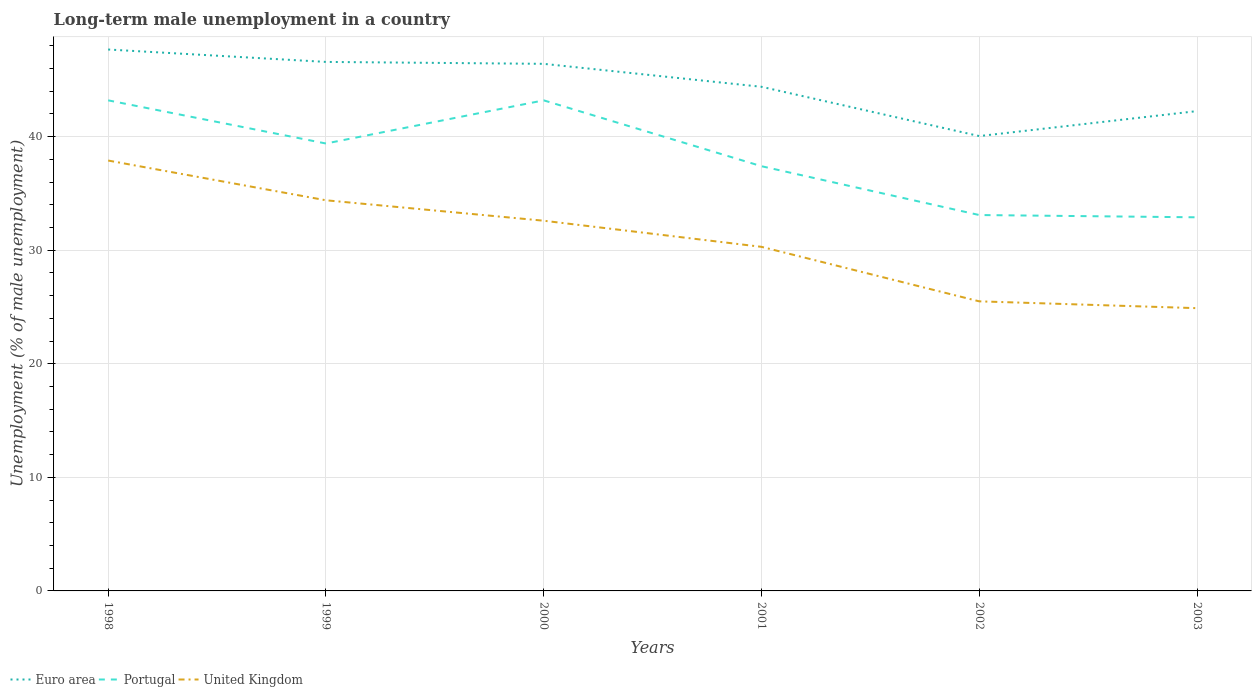How many different coloured lines are there?
Give a very brief answer. 3. Across all years, what is the maximum percentage of long-term unemployed male population in Euro area?
Give a very brief answer. 40.05. What is the total percentage of long-term unemployed male population in United Kingdom in the graph?
Provide a short and direct response. 13. What is the difference between the highest and the second highest percentage of long-term unemployed male population in Portugal?
Offer a very short reply. 10.3. What is the difference between the highest and the lowest percentage of long-term unemployed male population in Euro area?
Your response must be concise. 3. Is the percentage of long-term unemployed male population in Euro area strictly greater than the percentage of long-term unemployed male population in United Kingdom over the years?
Your response must be concise. No. How many lines are there?
Make the answer very short. 3. What is the difference between two consecutive major ticks on the Y-axis?
Offer a terse response. 10. How are the legend labels stacked?
Ensure brevity in your answer.  Horizontal. What is the title of the graph?
Your response must be concise. Long-term male unemployment in a country. What is the label or title of the X-axis?
Your response must be concise. Years. What is the label or title of the Y-axis?
Offer a very short reply. Unemployment (% of male unemployment). What is the Unemployment (% of male unemployment) in Euro area in 1998?
Make the answer very short. 47.68. What is the Unemployment (% of male unemployment) in Portugal in 1998?
Your answer should be very brief. 43.2. What is the Unemployment (% of male unemployment) of United Kingdom in 1998?
Keep it short and to the point. 37.9. What is the Unemployment (% of male unemployment) in Euro area in 1999?
Keep it short and to the point. 46.58. What is the Unemployment (% of male unemployment) of Portugal in 1999?
Give a very brief answer. 39.4. What is the Unemployment (% of male unemployment) in United Kingdom in 1999?
Keep it short and to the point. 34.4. What is the Unemployment (% of male unemployment) in Euro area in 2000?
Keep it short and to the point. 46.42. What is the Unemployment (% of male unemployment) of Portugal in 2000?
Provide a short and direct response. 43.2. What is the Unemployment (% of male unemployment) in United Kingdom in 2000?
Your response must be concise. 32.6. What is the Unemployment (% of male unemployment) of Euro area in 2001?
Make the answer very short. 44.39. What is the Unemployment (% of male unemployment) in Portugal in 2001?
Give a very brief answer. 37.4. What is the Unemployment (% of male unemployment) of United Kingdom in 2001?
Keep it short and to the point. 30.3. What is the Unemployment (% of male unemployment) of Euro area in 2002?
Your response must be concise. 40.05. What is the Unemployment (% of male unemployment) of Portugal in 2002?
Your answer should be very brief. 33.1. What is the Unemployment (% of male unemployment) of United Kingdom in 2002?
Offer a terse response. 25.5. What is the Unemployment (% of male unemployment) of Euro area in 2003?
Offer a very short reply. 42.25. What is the Unemployment (% of male unemployment) of Portugal in 2003?
Provide a succinct answer. 32.9. What is the Unemployment (% of male unemployment) of United Kingdom in 2003?
Provide a short and direct response. 24.9. Across all years, what is the maximum Unemployment (% of male unemployment) of Euro area?
Your response must be concise. 47.68. Across all years, what is the maximum Unemployment (% of male unemployment) of Portugal?
Your response must be concise. 43.2. Across all years, what is the maximum Unemployment (% of male unemployment) in United Kingdom?
Your response must be concise. 37.9. Across all years, what is the minimum Unemployment (% of male unemployment) of Euro area?
Your answer should be very brief. 40.05. Across all years, what is the minimum Unemployment (% of male unemployment) of Portugal?
Provide a short and direct response. 32.9. Across all years, what is the minimum Unemployment (% of male unemployment) of United Kingdom?
Your answer should be compact. 24.9. What is the total Unemployment (% of male unemployment) in Euro area in the graph?
Your answer should be compact. 267.38. What is the total Unemployment (% of male unemployment) in Portugal in the graph?
Offer a very short reply. 229.2. What is the total Unemployment (% of male unemployment) in United Kingdom in the graph?
Offer a terse response. 185.6. What is the difference between the Unemployment (% of male unemployment) in Euro area in 1998 and that in 1999?
Your response must be concise. 1.09. What is the difference between the Unemployment (% of male unemployment) of United Kingdom in 1998 and that in 1999?
Offer a terse response. 3.5. What is the difference between the Unemployment (% of male unemployment) in Euro area in 1998 and that in 2000?
Your response must be concise. 1.26. What is the difference between the Unemployment (% of male unemployment) of Portugal in 1998 and that in 2000?
Give a very brief answer. 0. What is the difference between the Unemployment (% of male unemployment) in United Kingdom in 1998 and that in 2000?
Give a very brief answer. 5.3. What is the difference between the Unemployment (% of male unemployment) in Euro area in 1998 and that in 2001?
Keep it short and to the point. 3.28. What is the difference between the Unemployment (% of male unemployment) of United Kingdom in 1998 and that in 2001?
Keep it short and to the point. 7.6. What is the difference between the Unemployment (% of male unemployment) in Euro area in 1998 and that in 2002?
Make the answer very short. 7.62. What is the difference between the Unemployment (% of male unemployment) in Portugal in 1998 and that in 2002?
Your answer should be compact. 10.1. What is the difference between the Unemployment (% of male unemployment) in United Kingdom in 1998 and that in 2002?
Give a very brief answer. 12.4. What is the difference between the Unemployment (% of male unemployment) in Euro area in 1998 and that in 2003?
Your answer should be very brief. 5.42. What is the difference between the Unemployment (% of male unemployment) of United Kingdom in 1998 and that in 2003?
Your answer should be very brief. 13. What is the difference between the Unemployment (% of male unemployment) in Euro area in 1999 and that in 2000?
Provide a succinct answer. 0.17. What is the difference between the Unemployment (% of male unemployment) of United Kingdom in 1999 and that in 2000?
Your answer should be very brief. 1.8. What is the difference between the Unemployment (% of male unemployment) in Euro area in 1999 and that in 2001?
Offer a terse response. 2.19. What is the difference between the Unemployment (% of male unemployment) of United Kingdom in 1999 and that in 2001?
Your response must be concise. 4.1. What is the difference between the Unemployment (% of male unemployment) of Euro area in 1999 and that in 2002?
Keep it short and to the point. 6.53. What is the difference between the Unemployment (% of male unemployment) in Euro area in 1999 and that in 2003?
Your answer should be very brief. 4.33. What is the difference between the Unemployment (% of male unemployment) of United Kingdom in 1999 and that in 2003?
Provide a succinct answer. 9.5. What is the difference between the Unemployment (% of male unemployment) of Euro area in 2000 and that in 2001?
Make the answer very short. 2.02. What is the difference between the Unemployment (% of male unemployment) of United Kingdom in 2000 and that in 2001?
Make the answer very short. 2.3. What is the difference between the Unemployment (% of male unemployment) in Euro area in 2000 and that in 2002?
Your answer should be very brief. 6.36. What is the difference between the Unemployment (% of male unemployment) in United Kingdom in 2000 and that in 2002?
Provide a short and direct response. 7.1. What is the difference between the Unemployment (% of male unemployment) of Euro area in 2000 and that in 2003?
Keep it short and to the point. 4.16. What is the difference between the Unemployment (% of male unemployment) of Portugal in 2000 and that in 2003?
Your answer should be very brief. 10.3. What is the difference between the Unemployment (% of male unemployment) in United Kingdom in 2000 and that in 2003?
Make the answer very short. 7.7. What is the difference between the Unemployment (% of male unemployment) of Euro area in 2001 and that in 2002?
Your response must be concise. 4.34. What is the difference between the Unemployment (% of male unemployment) of Euro area in 2001 and that in 2003?
Give a very brief answer. 2.14. What is the difference between the Unemployment (% of male unemployment) of United Kingdom in 2001 and that in 2003?
Offer a very short reply. 5.4. What is the difference between the Unemployment (% of male unemployment) of Euro area in 2002 and that in 2003?
Give a very brief answer. -2.2. What is the difference between the Unemployment (% of male unemployment) of Portugal in 2002 and that in 2003?
Give a very brief answer. 0.2. What is the difference between the Unemployment (% of male unemployment) in Euro area in 1998 and the Unemployment (% of male unemployment) in Portugal in 1999?
Ensure brevity in your answer.  8.28. What is the difference between the Unemployment (% of male unemployment) of Euro area in 1998 and the Unemployment (% of male unemployment) of United Kingdom in 1999?
Make the answer very short. 13.28. What is the difference between the Unemployment (% of male unemployment) of Euro area in 1998 and the Unemployment (% of male unemployment) of Portugal in 2000?
Your answer should be very brief. 4.48. What is the difference between the Unemployment (% of male unemployment) in Euro area in 1998 and the Unemployment (% of male unemployment) in United Kingdom in 2000?
Offer a terse response. 15.08. What is the difference between the Unemployment (% of male unemployment) of Portugal in 1998 and the Unemployment (% of male unemployment) of United Kingdom in 2000?
Your answer should be very brief. 10.6. What is the difference between the Unemployment (% of male unemployment) of Euro area in 1998 and the Unemployment (% of male unemployment) of Portugal in 2001?
Provide a succinct answer. 10.28. What is the difference between the Unemployment (% of male unemployment) of Euro area in 1998 and the Unemployment (% of male unemployment) of United Kingdom in 2001?
Give a very brief answer. 17.38. What is the difference between the Unemployment (% of male unemployment) in Portugal in 1998 and the Unemployment (% of male unemployment) in United Kingdom in 2001?
Offer a very short reply. 12.9. What is the difference between the Unemployment (% of male unemployment) in Euro area in 1998 and the Unemployment (% of male unemployment) in Portugal in 2002?
Keep it short and to the point. 14.58. What is the difference between the Unemployment (% of male unemployment) in Euro area in 1998 and the Unemployment (% of male unemployment) in United Kingdom in 2002?
Provide a short and direct response. 22.18. What is the difference between the Unemployment (% of male unemployment) of Portugal in 1998 and the Unemployment (% of male unemployment) of United Kingdom in 2002?
Give a very brief answer. 17.7. What is the difference between the Unemployment (% of male unemployment) in Euro area in 1998 and the Unemployment (% of male unemployment) in Portugal in 2003?
Your answer should be very brief. 14.78. What is the difference between the Unemployment (% of male unemployment) in Euro area in 1998 and the Unemployment (% of male unemployment) in United Kingdom in 2003?
Make the answer very short. 22.78. What is the difference between the Unemployment (% of male unemployment) in Euro area in 1999 and the Unemployment (% of male unemployment) in Portugal in 2000?
Your answer should be compact. 3.38. What is the difference between the Unemployment (% of male unemployment) of Euro area in 1999 and the Unemployment (% of male unemployment) of United Kingdom in 2000?
Offer a very short reply. 13.98. What is the difference between the Unemployment (% of male unemployment) in Euro area in 1999 and the Unemployment (% of male unemployment) in Portugal in 2001?
Your response must be concise. 9.18. What is the difference between the Unemployment (% of male unemployment) in Euro area in 1999 and the Unemployment (% of male unemployment) in United Kingdom in 2001?
Your answer should be compact. 16.28. What is the difference between the Unemployment (% of male unemployment) in Euro area in 1999 and the Unemployment (% of male unemployment) in Portugal in 2002?
Offer a very short reply. 13.48. What is the difference between the Unemployment (% of male unemployment) of Euro area in 1999 and the Unemployment (% of male unemployment) of United Kingdom in 2002?
Your answer should be compact. 21.08. What is the difference between the Unemployment (% of male unemployment) in Euro area in 1999 and the Unemployment (% of male unemployment) in Portugal in 2003?
Provide a succinct answer. 13.68. What is the difference between the Unemployment (% of male unemployment) in Euro area in 1999 and the Unemployment (% of male unemployment) in United Kingdom in 2003?
Provide a succinct answer. 21.68. What is the difference between the Unemployment (% of male unemployment) of Portugal in 1999 and the Unemployment (% of male unemployment) of United Kingdom in 2003?
Provide a short and direct response. 14.5. What is the difference between the Unemployment (% of male unemployment) in Euro area in 2000 and the Unemployment (% of male unemployment) in Portugal in 2001?
Provide a short and direct response. 9.02. What is the difference between the Unemployment (% of male unemployment) in Euro area in 2000 and the Unemployment (% of male unemployment) in United Kingdom in 2001?
Provide a succinct answer. 16.12. What is the difference between the Unemployment (% of male unemployment) of Euro area in 2000 and the Unemployment (% of male unemployment) of Portugal in 2002?
Your answer should be very brief. 13.32. What is the difference between the Unemployment (% of male unemployment) in Euro area in 2000 and the Unemployment (% of male unemployment) in United Kingdom in 2002?
Offer a very short reply. 20.92. What is the difference between the Unemployment (% of male unemployment) in Portugal in 2000 and the Unemployment (% of male unemployment) in United Kingdom in 2002?
Make the answer very short. 17.7. What is the difference between the Unemployment (% of male unemployment) in Euro area in 2000 and the Unemployment (% of male unemployment) in Portugal in 2003?
Provide a short and direct response. 13.52. What is the difference between the Unemployment (% of male unemployment) in Euro area in 2000 and the Unemployment (% of male unemployment) in United Kingdom in 2003?
Your answer should be compact. 21.52. What is the difference between the Unemployment (% of male unemployment) of Portugal in 2000 and the Unemployment (% of male unemployment) of United Kingdom in 2003?
Your answer should be very brief. 18.3. What is the difference between the Unemployment (% of male unemployment) in Euro area in 2001 and the Unemployment (% of male unemployment) in Portugal in 2002?
Offer a terse response. 11.29. What is the difference between the Unemployment (% of male unemployment) in Euro area in 2001 and the Unemployment (% of male unemployment) in United Kingdom in 2002?
Offer a very short reply. 18.89. What is the difference between the Unemployment (% of male unemployment) in Portugal in 2001 and the Unemployment (% of male unemployment) in United Kingdom in 2002?
Your response must be concise. 11.9. What is the difference between the Unemployment (% of male unemployment) in Euro area in 2001 and the Unemployment (% of male unemployment) in Portugal in 2003?
Your answer should be compact. 11.49. What is the difference between the Unemployment (% of male unemployment) of Euro area in 2001 and the Unemployment (% of male unemployment) of United Kingdom in 2003?
Offer a terse response. 19.49. What is the difference between the Unemployment (% of male unemployment) of Portugal in 2001 and the Unemployment (% of male unemployment) of United Kingdom in 2003?
Provide a short and direct response. 12.5. What is the difference between the Unemployment (% of male unemployment) in Euro area in 2002 and the Unemployment (% of male unemployment) in Portugal in 2003?
Provide a succinct answer. 7.15. What is the difference between the Unemployment (% of male unemployment) of Euro area in 2002 and the Unemployment (% of male unemployment) of United Kingdom in 2003?
Provide a short and direct response. 15.15. What is the difference between the Unemployment (% of male unemployment) of Portugal in 2002 and the Unemployment (% of male unemployment) of United Kingdom in 2003?
Your response must be concise. 8.2. What is the average Unemployment (% of male unemployment) of Euro area per year?
Offer a terse response. 44.56. What is the average Unemployment (% of male unemployment) of Portugal per year?
Keep it short and to the point. 38.2. What is the average Unemployment (% of male unemployment) of United Kingdom per year?
Your response must be concise. 30.93. In the year 1998, what is the difference between the Unemployment (% of male unemployment) in Euro area and Unemployment (% of male unemployment) in Portugal?
Your answer should be compact. 4.48. In the year 1998, what is the difference between the Unemployment (% of male unemployment) in Euro area and Unemployment (% of male unemployment) in United Kingdom?
Offer a very short reply. 9.78. In the year 1999, what is the difference between the Unemployment (% of male unemployment) in Euro area and Unemployment (% of male unemployment) in Portugal?
Your answer should be compact. 7.18. In the year 1999, what is the difference between the Unemployment (% of male unemployment) of Euro area and Unemployment (% of male unemployment) of United Kingdom?
Ensure brevity in your answer.  12.18. In the year 2000, what is the difference between the Unemployment (% of male unemployment) in Euro area and Unemployment (% of male unemployment) in Portugal?
Your answer should be very brief. 3.22. In the year 2000, what is the difference between the Unemployment (% of male unemployment) of Euro area and Unemployment (% of male unemployment) of United Kingdom?
Offer a terse response. 13.82. In the year 2001, what is the difference between the Unemployment (% of male unemployment) of Euro area and Unemployment (% of male unemployment) of Portugal?
Give a very brief answer. 6.99. In the year 2001, what is the difference between the Unemployment (% of male unemployment) of Euro area and Unemployment (% of male unemployment) of United Kingdom?
Provide a short and direct response. 14.09. In the year 2002, what is the difference between the Unemployment (% of male unemployment) of Euro area and Unemployment (% of male unemployment) of Portugal?
Ensure brevity in your answer.  6.95. In the year 2002, what is the difference between the Unemployment (% of male unemployment) in Euro area and Unemployment (% of male unemployment) in United Kingdom?
Offer a very short reply. 14.55. In the year 2003, what is the difference between the Unemployment (% of male unemployment) of Euro area and Unemployment (% of male unemployment) of Portugal?
Provide a short and direct response. 9.35. In the year 2003, what is the difference between the Unemployment (% of male unemployment) of Euro area and Unemployment (% of male unemployment) of United Kingdom?
Your response must be concise. 17.35. What is the ratio of the Unemployment (% of male unemployment) in Euro area in 1998 to that in 1999?
Offer a terse response. 1.02. What is the ratio of the Unemployment (% of male unemployment) in Portugal in 1998 to that in 1999?
Offer a terse response. 1.1. What is the ratio of the Unemployment (% of male unemployment) in United Kingdom in 1998 to that in 1999?
Make the answer very short. 1.1. What is the ratio of the Unemployment (% of male unemployment) of Euro area in 1998 to that in 2000?
Keep it short and to the point. 1.03. What is the ratio of the Unemployment (% of male unemployment) of United Kingdom in 1998 to that in 2000?
Keep it short and to the point. 1.16. What is the ratio of the Unemployment (% of male unemployment) of Euro area in 1998 to that in 2001?
Give a very brief answer. 1.07. What is the ratio of the Unemployment (% of male unemployment) in Portugal in 1998 to that in 2001?
Your answer should be compact. 1.16. What is the ratio of the Unemployment (% of male unemployment) of United Kingdom in 1998 to that in 2001?
Ensure brevity in your answer.  1.25. What is the ratio of the Unemployment (% of male unemployment) of Euro area in 1998 to that in 2002?
Your response must be concise. 1.19. What is the ratio of the Unemployment (% of male unemployment) in Portugal in 1998 to that in 2002?
Provide a succinct answer. 1.31. What is the ratio of the Unemployment (% of male unemployment) of United Kingdom in 1998 to that in 2002?
Provide a succinct answer. 1.49. What is the ratio of the Unemployment (% of male unemployment) of Euro area in 1998 to that in 2003?
Ensure brevity in your answer.  1.13. What is the ratio of the Unemployment (% of male unemployment) of Portugal in 1998 to that in 2003?
Provide a succinct answer. 1.31. What is the ratio of the Unemployment (% of male unemployment) in United Kingdom in 1998 to that in 2003?
Your answer should be compact. 1.52. What is the ratio of the Unemployment (% of male unemployment) in Portugal in 1999 to that in 2000?
Keep it short and to the point. 0.91. What is the ratio of the Unemployment (% of male unemployment) of United Kingdom in 1999 to that in 2000?
Offer a terse response. 1.06. What is the ratio of the Unemployment (% of male unemployment) of Euro area in 1999 to that in 2001?
Provide a short and direct response. 1.05. What is the ratio of the Unemployment (% of male unemployment) of Portugal in 1999 to that in 2001?
Ensure brevity in your answer.  1.05. What is the ratio of the Unemployment (% of male unemployment) of United Kingdom in 1999 to that in 2001?
Ensure brevity in your answer.  1.14. What is the ratio of the Unemployment (% of male unemployment) of Euro area in 1999 to that in 2002?
Your answer should be compact. 1.16. What is the ratio of the Unemployment (% of male unemployment) in Portugal in 1999 to that in 2002?
Give a very brief answer. 1.19. What is the ratio of the Unemployment (% of male unemployment) in United Kingdom in 1999 to that in 2002?
Your response must be concise. 1.35. What is the ratio of the Unemployment (% of male unemployment) of Euro area in 1999 to that in 2003?
Give a very brief answer. 1.1. What is the ratio of the Unemployment (% of male unemployment) of Portugal in 1999 to that in 2003?
Offer a terse response. 1.2. What is the ratio of the Unemployment (% of male unemployment) of United Kingdom in 1999 to that in 2003?
Offer a terse response. 1.38. What is the ratio of the Unemployment (% of male unemployment) of Euro area in 2000 to that in 2001?
Provide a short and direct response. 1.05. What is the ratio of the Unemployment (% of male unemployment) in Portugal in 2000 to that in 2001?
Ensure brevity in your answer.  1.16. What is the ratio of the Unemployment (% of male unemployment) of United Kingdom in 2000 to that in 2001?
Make the answer very short. 1.08. What is the ratio of the Unemployment (% of male unemployment) of Euro area in 2000 to that in 2002?
Make the answer very short. 1.16. What is the ratio of the Unemployment (% of male unemployment) in Portugal in 2000 to that in 2002?
Your response must be concise. 1.31. What is the ratio of the Unemployment (% of male unemployment) in United Kingdom in 2000 to that in 2002?
Ensure brevity in your answer.  1.28. What is the ratio of the Unemployment (% of male unemployment) of Euro area in 2000 to that in 2003?
Keep it short and to the point. 1.1. What is the ratio of the Unemployment (% of male unemployment) in Portugal in 2000 to that in 2003?
Give a very brief answer. 1.31. What is the ratio of the Unemployment (% of male unemployment) in United Kingdom in 2000 to that in 2003?
Give a very brief answer. 1.31. What is the ratio of the Unemployment (% of male unemployment) of Euro area in 2001 to that in 2002?
Your answer should be compact. 1.11. What is the ratio of the Unemployment (% of male unemployment) in Portugal in 2001 to that in 2002?
Give a very brief answer. 1.13. What is the ratio of the Unemployment (% of male unemployment) of United Kingdom in 2001 to that in 2002?
Offer a terse response. 1.19. What is the ratio of the Unemployment (% of male unemployment) in Euro area in 2001 to that in 2003?
Your answer should be very brief. 1.05. What is the ratio of the Unemployment (% of male unemployment) in Portugal in 2001 to that in 2003?
Offer a terse response. 1.14. What is the ratio of the Unemployment (% of male unemployment) of United Kingdom in 2001 to that in 2003?
Provide a short and direct response. 1.22. What is the ratio of the Unemployment (% of male unemployment) of Euro area in 2002 to that in 2003?
Your answer should be compact. 0.95. What is the ratio of the Unemployment (% of male unemployment) in United Kingdom in 2002 to that in 2003?
Keep it short and to the point. 1.02. What is the difference between the highest and the second highest Unemployment (% of male unemployment) in Euro area?
Offer a terse response. 1.09. What is the difference between the highest and the second highest Unemployment (% of male unemployment) in Portugal?
Provide a succinct answer. 0. What is the difference between the highest and the lowest Unemployment (% of male unemployment) in Euro area?
Offer a very short reply. 7.62. 